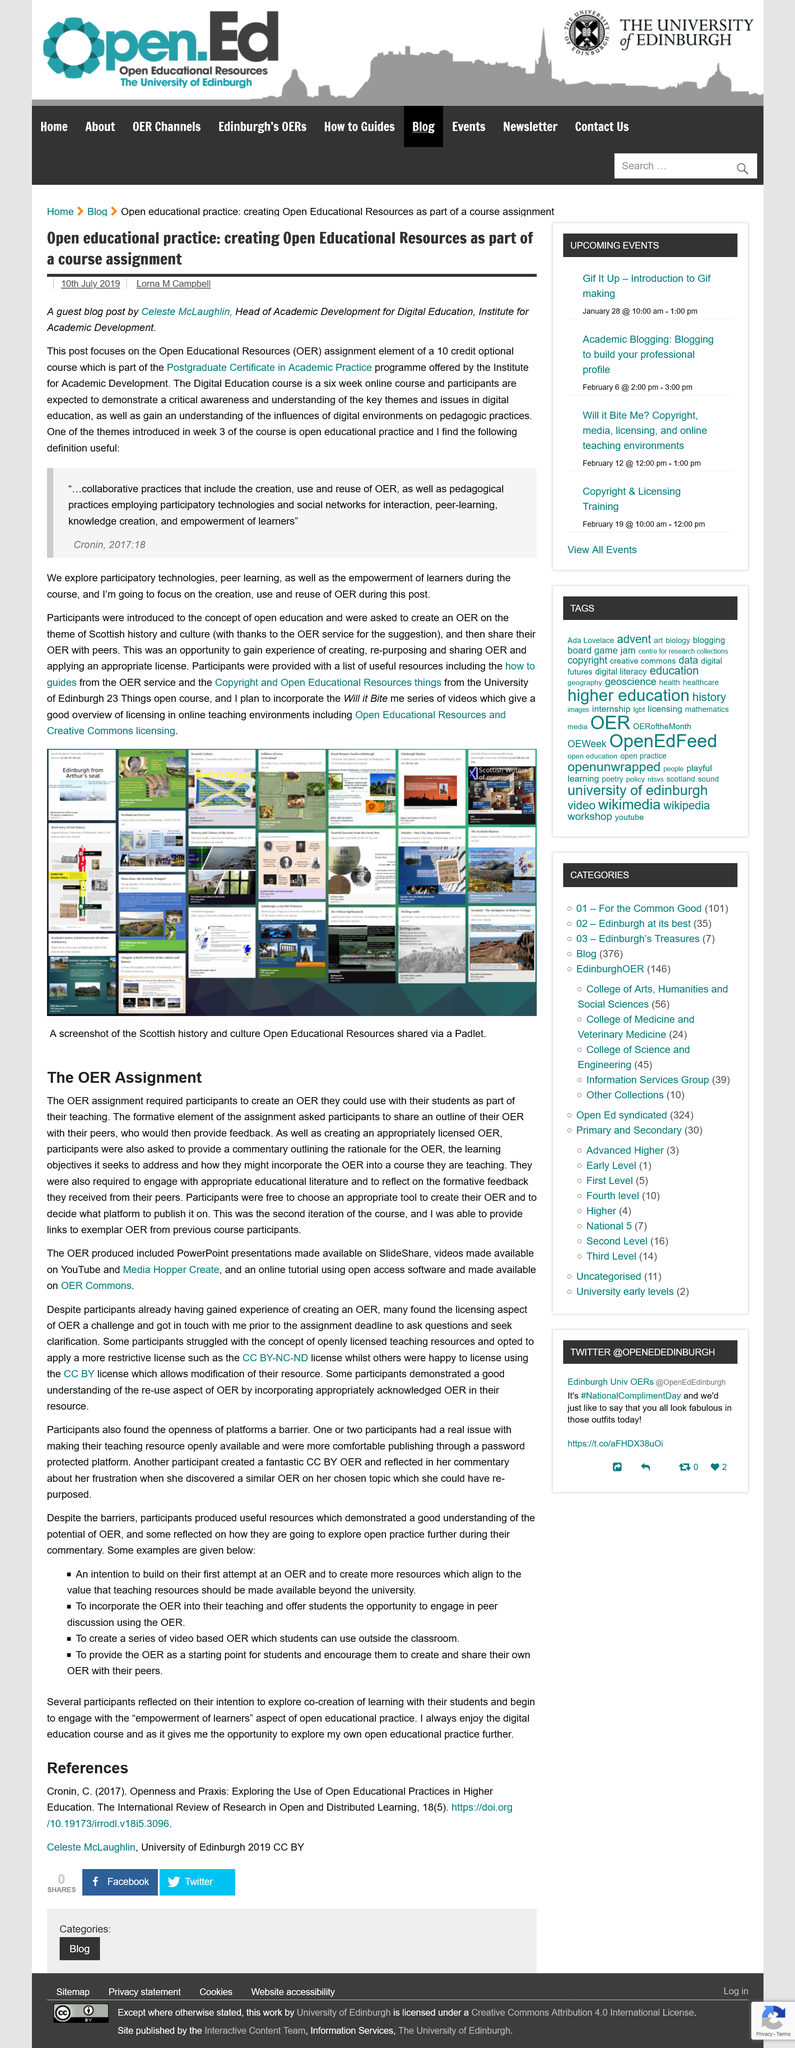List a handful of essential elements in this visual. The focus of the service was on Open Educational Resources (OER). There are four examples given in the article. Open educational practice is not a theme introduced in week 2 of the Institute for Academic Development's Digital Education course, but rather in week 3. The OER presentations can be accessed on SlideShare. The OER videos can be accessed on YouTube and Media Hopper Create. 